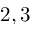Convert formula to latex. <formula><loc_0><loc_0><loc_500><loc_500>2 , 3</formula> 